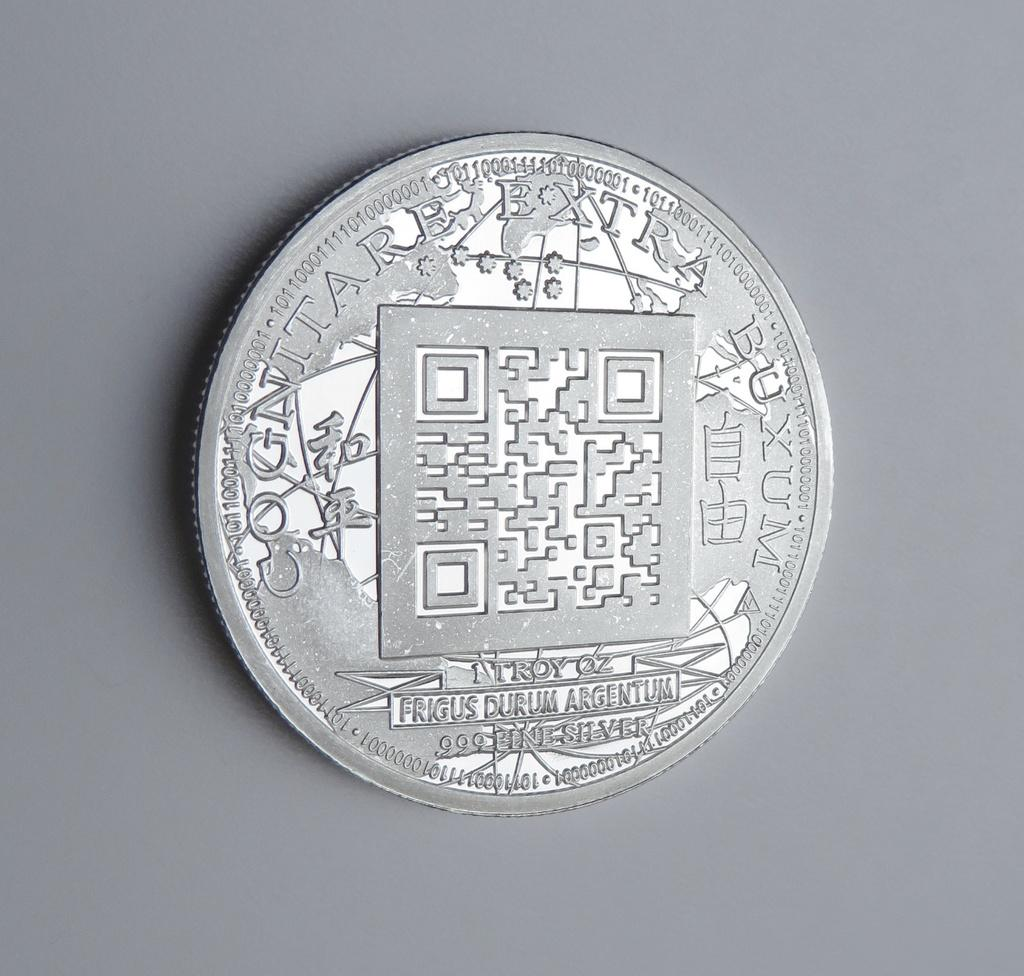<image>
Describe the image concisely. Some sort of coin or token that says Cognitarb Extra Buxum around the edge. 